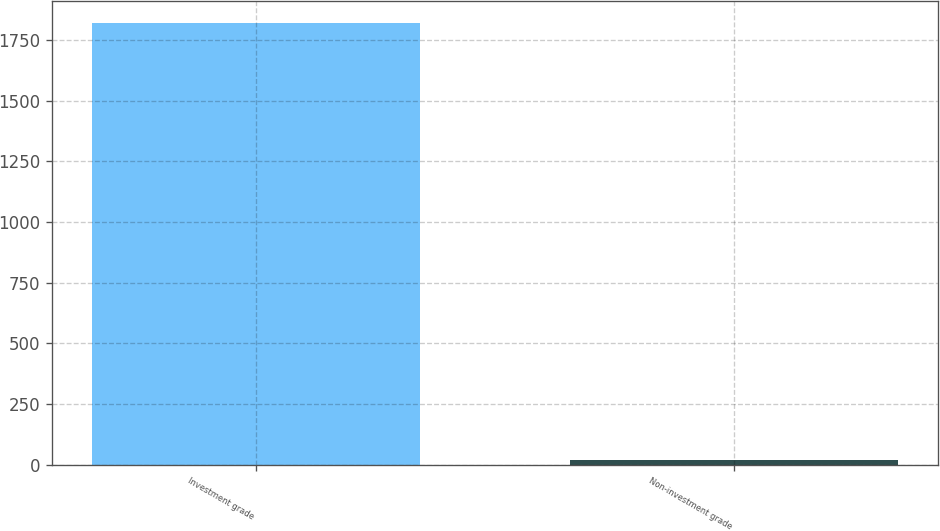Convert chart. <chart><loc_0><loc_0><loc_500><loc_500><bar_chart><fcel>Investment grade<fcel>Non-investment grade<nl><fcel>1818<fcel>20<nl></chart> 